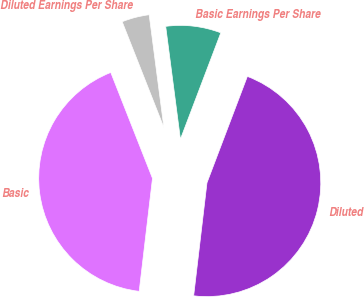Convert chart to OTSL. <chart><loc_0><loc_0><loc_500><loc_500><pie_chart><fcel>Basic Earnings Per Share<fcel>Diluted Earnings Per Share<fcel>Basic<fcel>Diluted<nl><fcel>7.84%<fcel>3.91%<fcel>42.16%<fcel>46.09%<nl></chart> 